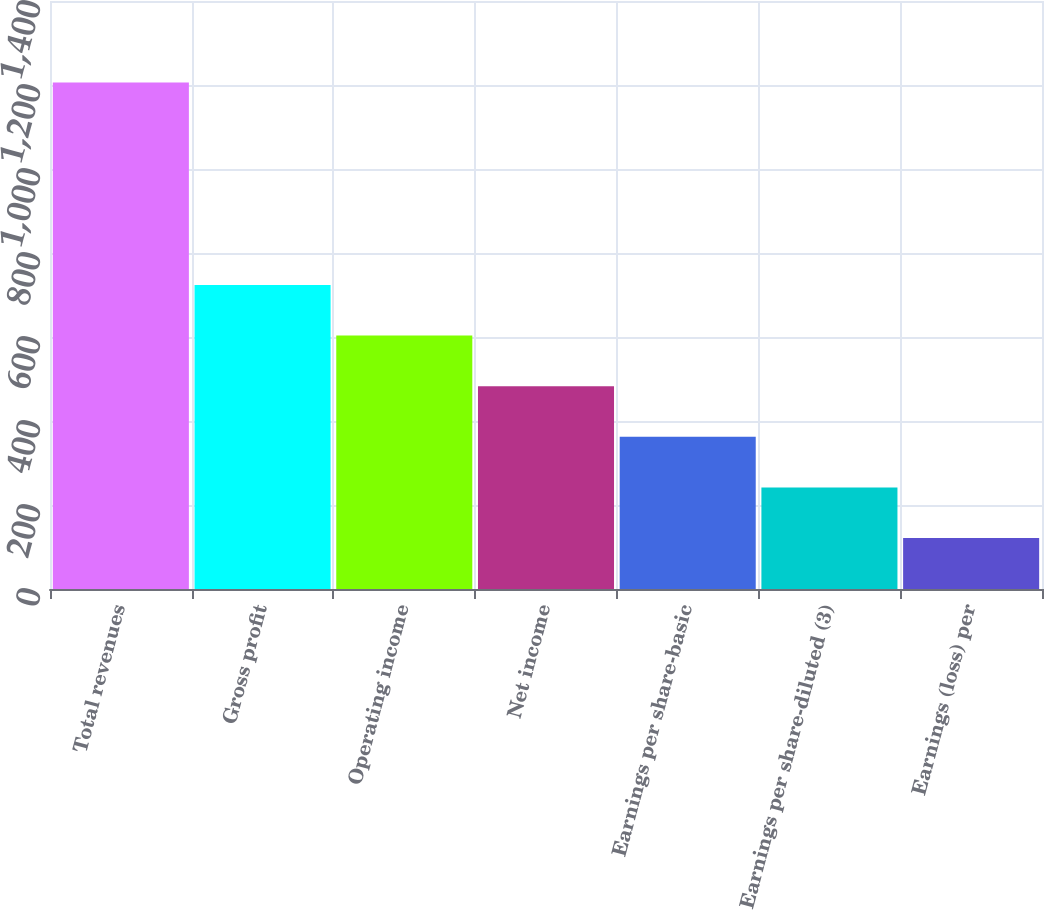Convert chart to OTSL. <chart><loc_0><loc_0><loc_500><loc_500><bar_chart><fcel>Total revenues<fcel>Gross profit<fcel>Operating income<fcel>Net income<fcel>Earnings per share-basic<fcel>Earnings per share-diluted (3)<fcel>Earnings (loss) per<nl><fcel>1206<fcel>723.87<fcel>603.33<fcel>482.79<fcel>362.25<fcel>241.71<fcel>121.17<nl></chart> 